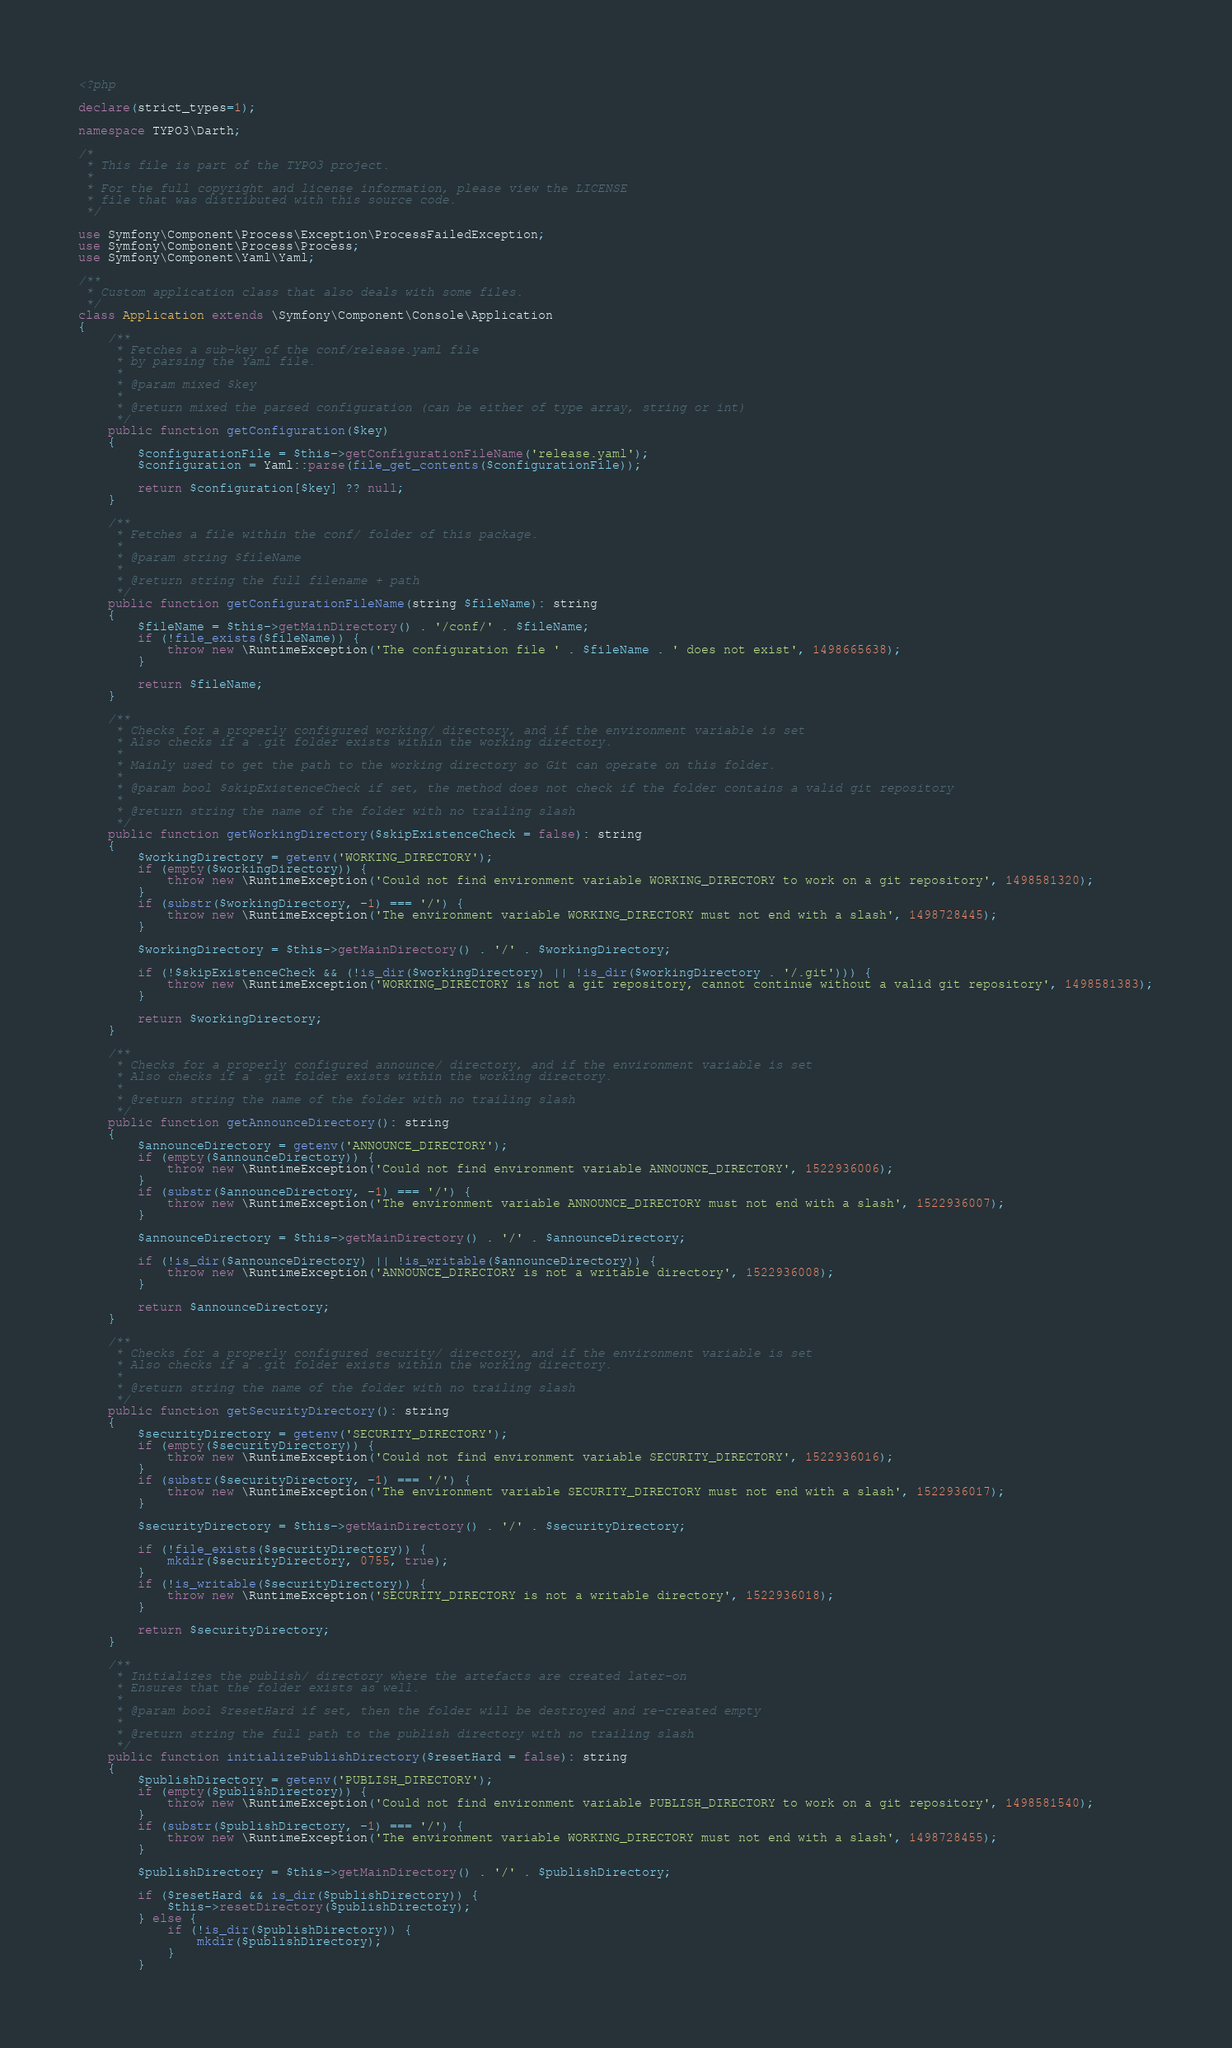Convert code to text. <code><loc_0><loc_0><loc_500><loc_500><_PHP_><?php

declare(strict_types=1);

namespace TYPO3\Darth;

/*
 * This file is part of the TYPO3 project.
 *
 * For the full copyright and license information, please view the LICENSE
 * file that was distributed with this source code.
 */

use Symfony\Component\Process\Exception\ProcessFailedException;
use Symfony\Component\Process\Process;
use Symfony\Component\Yaml\Yaml;

/**
 * Custom application class that also deals with some files.
 */
class Application extends \Symfony\Component\Console\Application
{
    /**
     * Fetches a sub-key of the conf/release.yaml file
     * by parsing the Yaml file.
     *
     * @param mixed $key
     *
     * @return mixed the parsed configuration (can be either of type array, string or int)
     */
    public function getConfiguration($key)
    {
        $configurationFile = $this->getConfigurationFileName('release.yaml');
        $configuration = Yaml::parse(file_get_contents($configurationFile));

        return $configuration[$key] ?? null;
    }

    /**
     * Fetches a file within the conf/ folder of this package.
     *
     * @param string $fileName
     *
     * @return string the full filename + path
     */
    public function getConfigurationFileName(string $fileName): string
    {
        $fileName = $this->getMainDirectory() . '/conf/' . $fileName;
        if (!file_exists($fileName)) {
            throw new \RuntimeException('The configuration file ' . $fileName . ' does not exist', 1498665638);
        }

        return $fileName;
    }

    /**
     * Checks for a properly configured working/ directory, and if the environment variable is set
     * Also checks if a .git folder exists within the working directory.
     *
     * Mainly used to get the path to the working directory so Git can operate on this folder.
     *
     * @param bool $skipExistenceCheck if set, the method does not check if the folder contains a valid git repository
     *
     * @return string the name of the folder with no trailing slash
     */
    public function getWorkingDirectory($skipExistenceCheck = false): string
    {
        $workingDirectory = getenv('WORKING_DIRECTORY');
        if (empty($workingDirectory)) {
            throw new \RuntimeException('Could not find environment variable WORKING_DIRECTORY to work on a git repository', 1498581320);
        }
        if (substr($workingDirectory, -1) === '/') {
            throw new \RuntimeException('The environment variable WORKING_DIRECTORY must not end with a slash', 1498728445);
        }

        $workingDirectory = $this->getMainDirectory() . '/' . $workingDirectory;

        if (!$skipExistenceCheck && (!is_dir($workingDirectory) || !is_dir($workingDirectory . '/.git'))) {
            throw new \RuntimeException('WORKING_DIRECTORY is not a git repository, cannot continue without a valid git repository', 1498581383);
        }

        return $workingDirectory;
    }

    /**
     * Checks for a properly configured announce/ directory, and if the environment variable is set
     * Also checks if a .git folder exists within the working directory.
     *
     * @return string the name of the folder with no trailing slash
     */
    public function getAnnounceDirectory(): string
    {
        $announceDirectory = getenv('ANNOUNCE_DIRECTORY');
        if (empty($announceDirectory)) {
            throw new \RuntimeException('Could not find environment variable ANNOUNCE_DIRECTORY', 1522936006);
        }
        if (substr($announceDirectory, -1) === '/') {
            throw new \RuntimeException('The environment variable ANNOUNCE_DIRECTORY must not end with a slash', 1522936007);
        }

        $announceDirectory = $this->getMainDirectory() . '/' . $announceDirectory;

        if (!is_dir($announceDirectory) || !is_writable($announceDirectory)) {
            throw new \RuntimeException('ANNOUNCE_DIRECTORY is not a writable directory', 1522936008);
        }

        return $announceDirectory;
    }

    /**
     * Checks for a properly configured security/ directory, and if the environment variable is set
     * Also checks if a .git folder exists within the working directory.
     *
     * @return string the name of the folder with no trailing slash
     */
    public function getSecurityDirectory(): string
    {
        $securityDirectory = getenv('SECURITY_DIRECTORY');
        if (empty($securityDirectory)) {
            throw new \RuntimeException('Could not find environment variable SECURITY_DIRECTORY', 1522936016);
        }
        if (substr($securityDirectory, -1) === '/') {
            throw new \RuntimeException('The environment variable SECURITY_DIRECTORY must not end with a slash', 1522936017);
        }

        $securityDirectory = $this->getMainDirectory() . '/' . $securityDirectory;

        if (!file_exists($securityDirectory)) {
            mkdir($securityDirectory, 0755, true);
        }
        if (!is_writable($securityDirectory)) {
            throw new \RuntimeException('SECURITY_DIRECTORY is not a writable directory', 1522936018);
        }

        return $securityDirectory;
    }

    /**
     * Initializes the publish/ directory where the artefacts are created later-on
     * Ensures that the folder exists as well.
     *
     * @param bool $resetHard if set, then the folder will be destroyed and re-created empty
     *
     * @return string the full path to the publish directory with no trailing slash
     */
    public function initializePublishDirectory($resetHard = false): string
    {
        $publishDirectory = getenv('PUBLISH_DIRECTORY');
        if (empty($publishDirectory)) {
            throw new \RuntimeException('Could not find environment variable PUBLISH_DIRECTORY to work on a git repository', 1498581540);
        }
        if (substr($publishDirectory, -1) === '/') {
            throw new \RuntimeException('The environment variable WORKING_DIRECTORY must not end with a slash', 1498728455);
        }

        $publishDirectory = $this->getMainDirectory() . '/' . $publishDirectory;

        if ($resetHard && is_dir($publishDirectory)) {
            $this->resetDirectory($publishDirectory);
        } else {
            if (!is_dir($publishDirectory)) {
                mkdir($publishDirectory);
            }
        }
</code> 